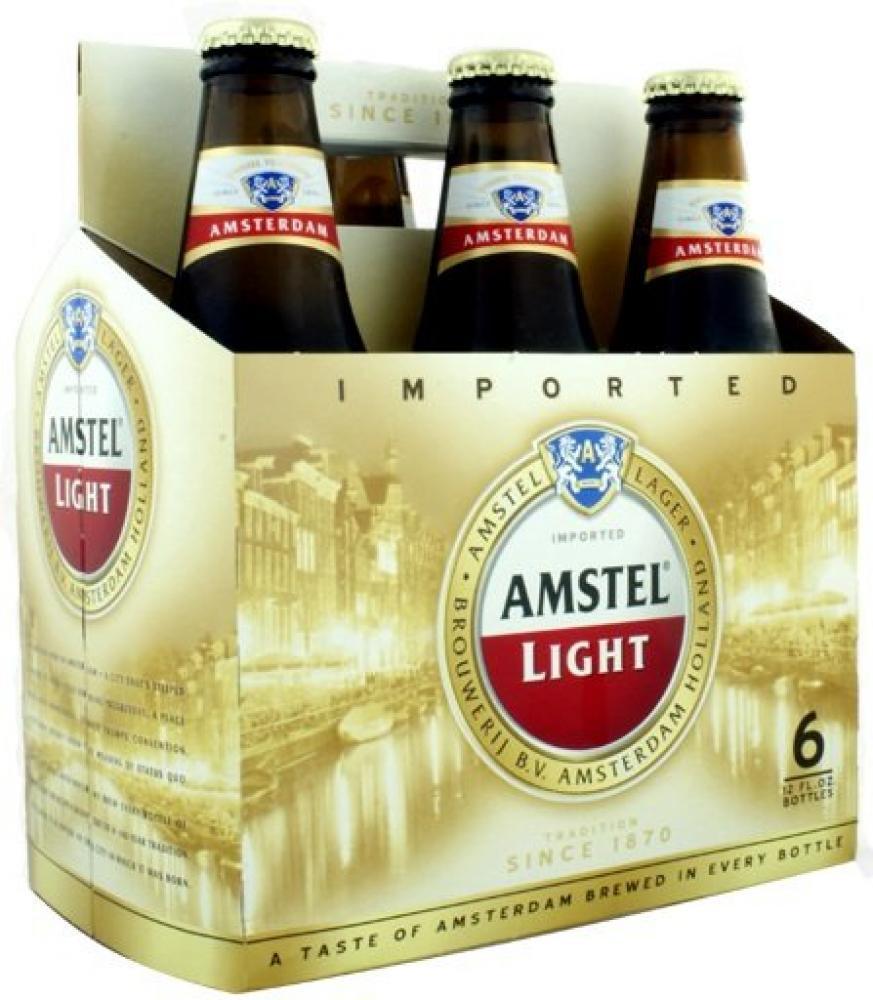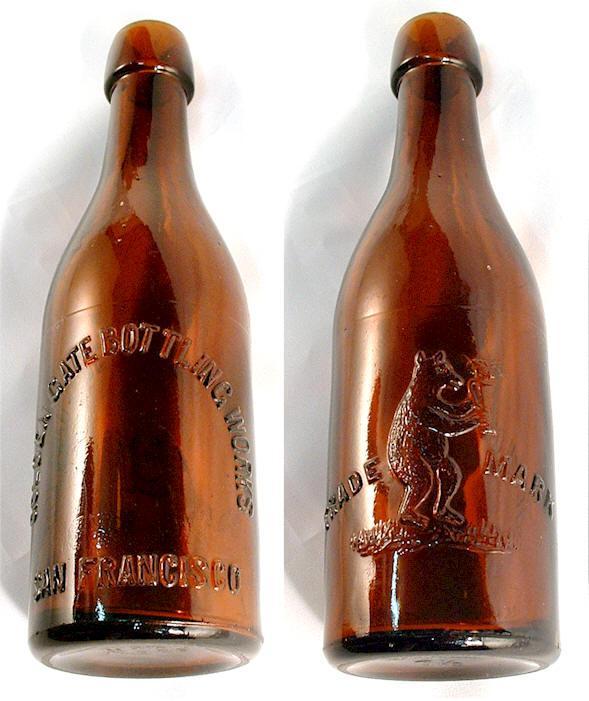The first image is the image on the left, the second image is the image on the right. Assess this claim about the two images: "In at least one image there are three bottles in a cardboard six pack holder.". Correct or not? Answer yes or no. Yes. The first image is the image on the left, the second image is the image on the right. Evaluate the accuracy of this statement regarding the images: "There are only two bottle visible in the right image.". Is it true? Answer yes or no. Yes. 